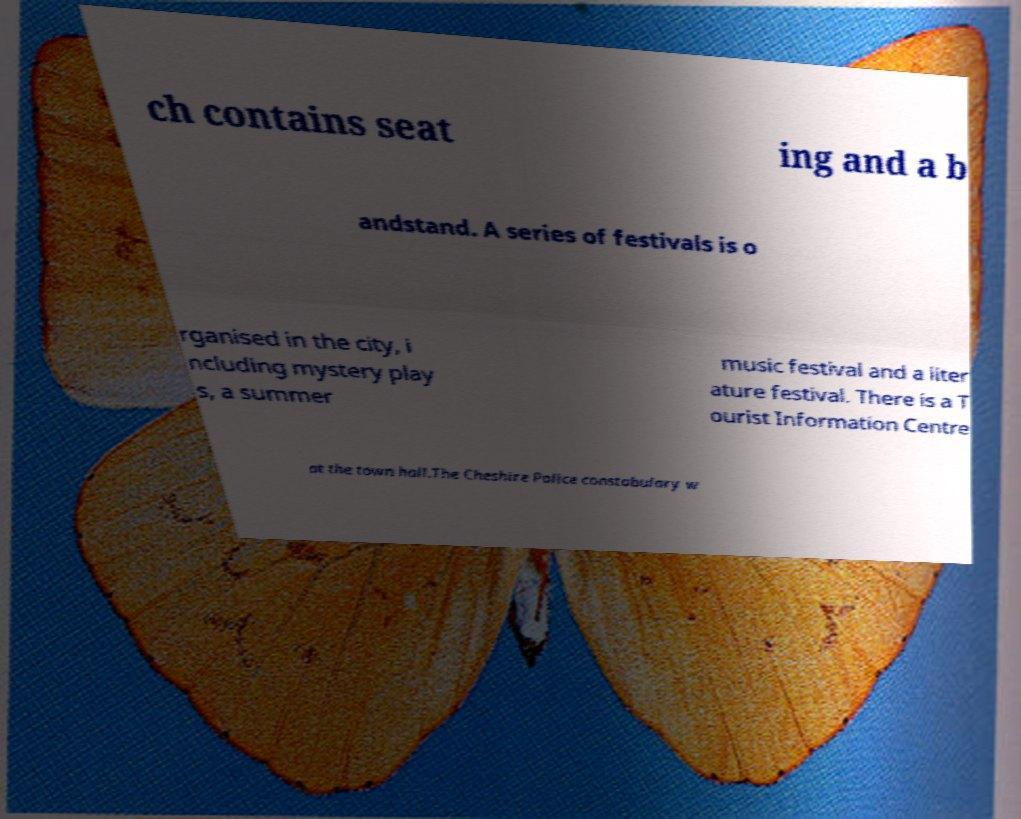I need the written content from this picture converted into text. Can you do that? ch contains seat ing and a b andstand. A series of festivals is o rganised in the city, i ncluding mystery play s, a summer music festival and a liter ature festival. There is a T ourist Information Centre at the town hall.The Cheshire Police constabulary w 